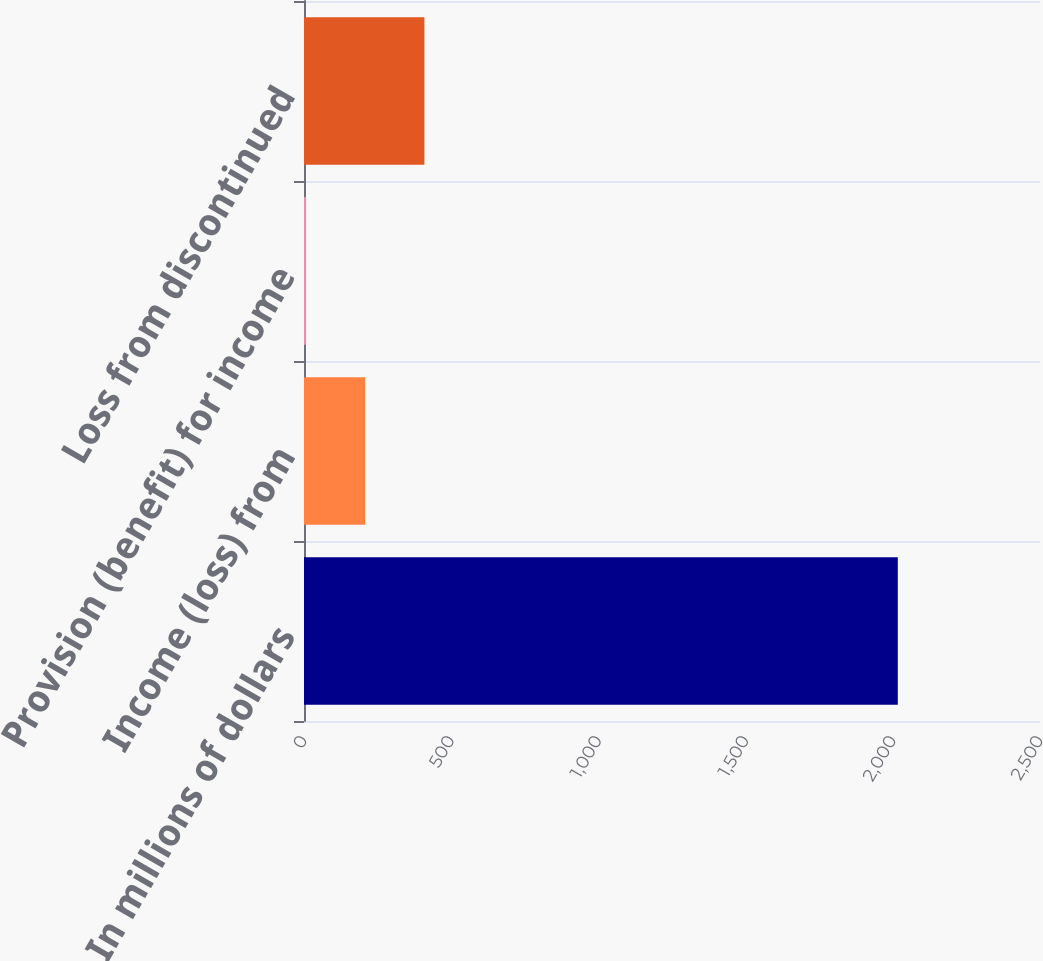Convert chart. <chart><loc_0><loc_0><loc_500><loc_500><bar_chart><fcel>In millions of dollars<fcel>Income (loss) from<fcel>Provision (benefit) for income<fcel>Loss from discontinued<nl><fcel>2017<fcel>208<fcel>7<fcel>409<nl></chart> 